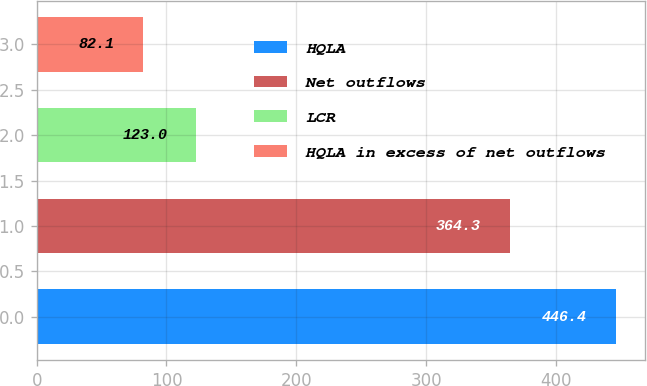<chart> <loc_0><loc_0><loc_500><loc_500><bar_chart><fcel>HQLA<fcel>Net outflows<fcel>LCR<fcel>HQLA in excess of net outflows<nl><fcel>446.4<fcel>364.3<fcel>123<fcel>82.1<nl></chart> 